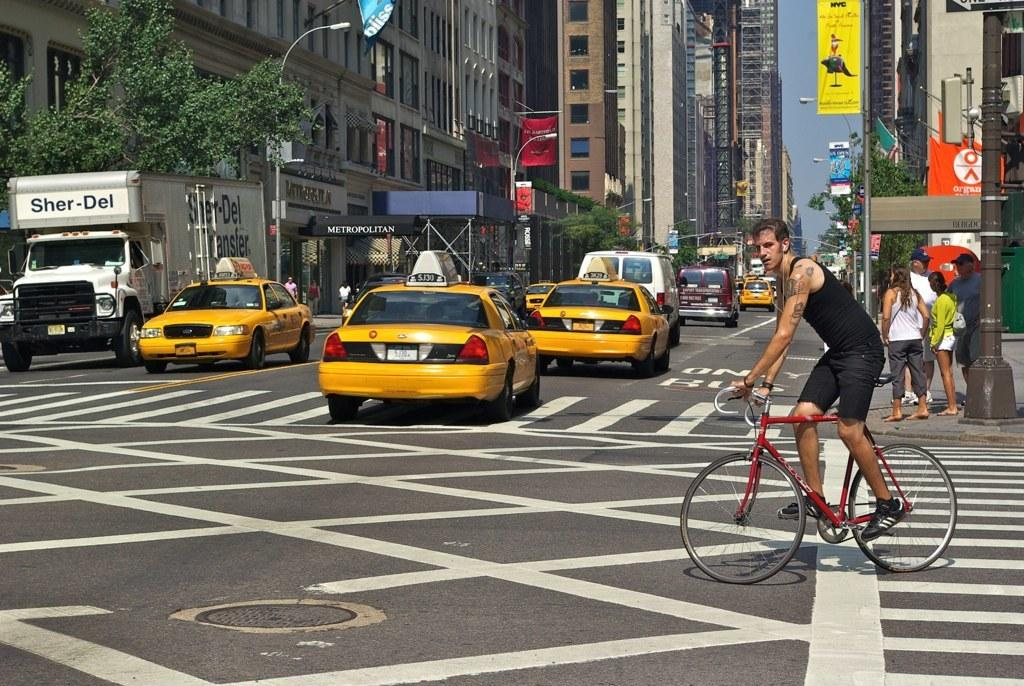Provide a one-sentence caption for the provided image. A busy New York street scene contains a canopy in the background which reads Metropolitan. 